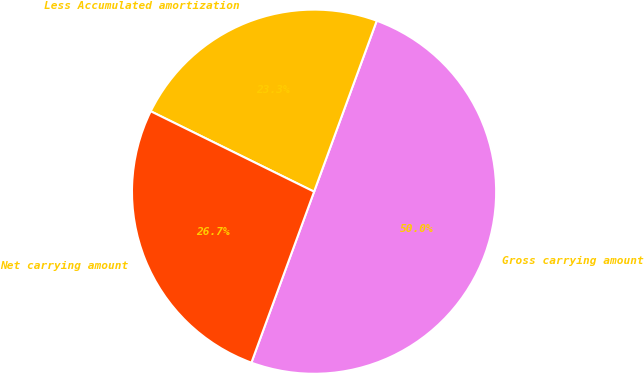Convert chart. <chart><loc_0><loc_0><loc_500><loc_500><pie_chart><fcel>Gross carrying amount<fcel>Less Accumulated amortization<fcel>Net carrying amount<nl><fcel>50.0%<fcel>23.31%<fcel>26.69%<nl></chart> 